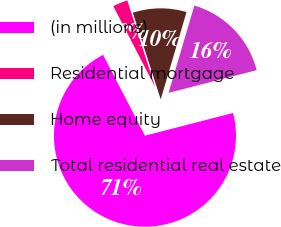Convert chart to OTSL. <chart><loc_0><loc_0><loc_500><loc_500><pie_chart><fcel>(in millions)<fcel>Residential mortgage<fcel>Home equity<fcel>Total residential real estate<nl><fcel>71.41%<fcel>2.65%<fcel>9.53%<fcel>16.41%<nl></chart> 